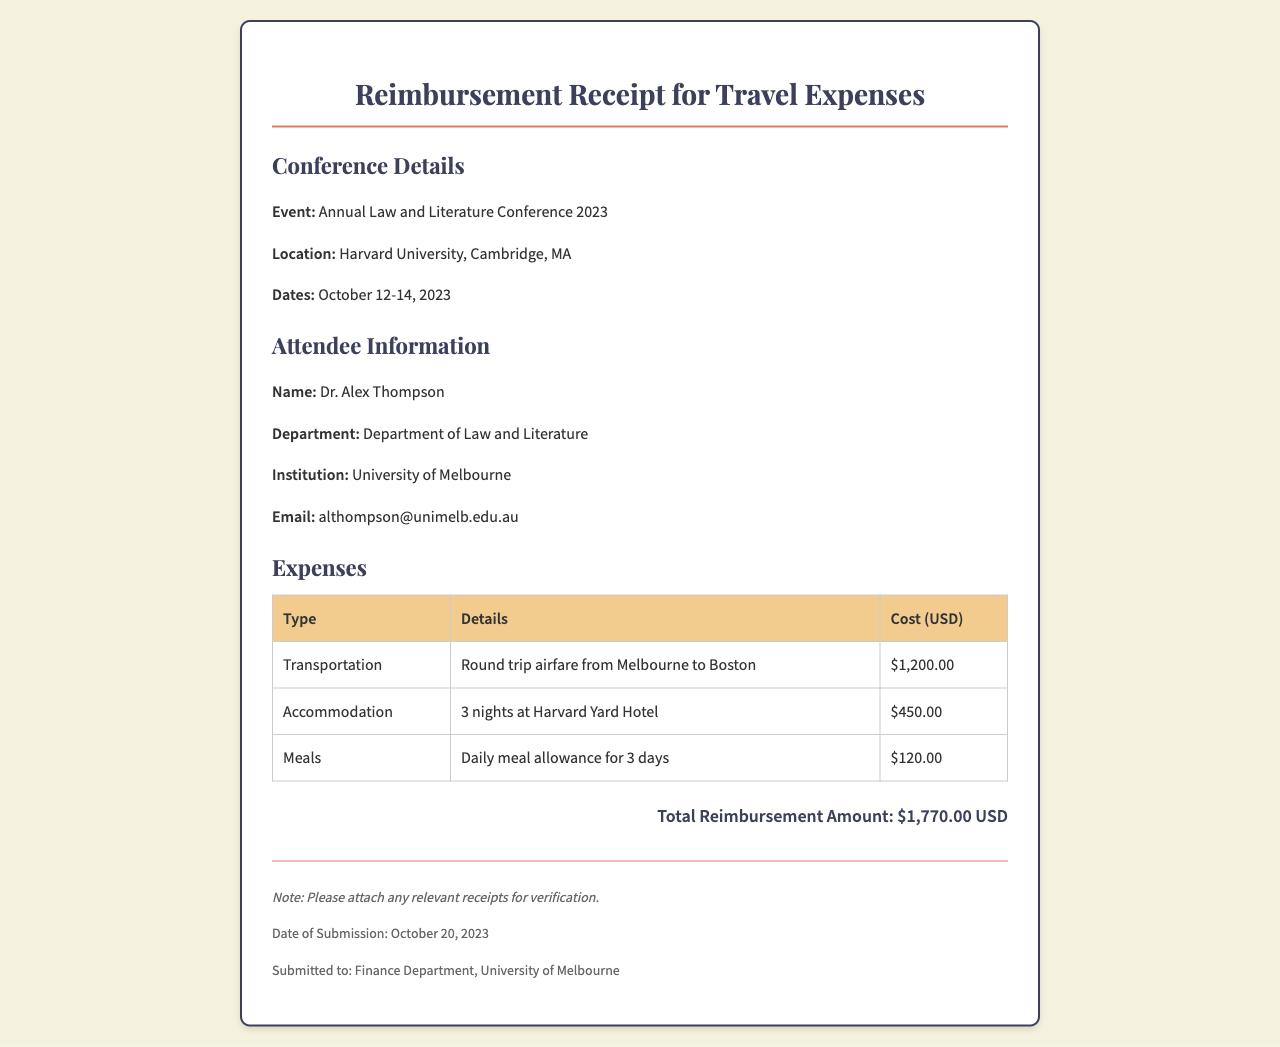What is the event name? The event name is specified in the conference details section of the document as "Annual Law and Literature Conference 2023."
Answer: Annual Law and Literature Conference 2023 Where was the conference held? The location of the conference is mentioned in the document under conference details as "Harvard University, Cambridge, MA."
Answer: Harvard University, Cambridge, MA Who submitted the reimbursement receipt? The name of the person who submitted the receipt can be found in the attendee information section, which states "Dr. Alex Thompson."
Answer: Dr. Alex Thompson What is the total reimbursement amount? The total reimbursement amount is listed in the total section of the document as "$1,770.00 USD."
Answer: $1,770.00 USD How many nights did the attendee stay at the hotel? The document mentions "3 nights" in the accommodation expense details.
Answer: 3 nights What type of transportation is listed? The type of transportation is specified in the expenses table as "Round trip airfare from Melbourne to Boston."
Answer: Round trip airfare from Melbourne to Boston What is the meal allowance amount? The routine mentioned for meals states "Daily meal allowance for 3 days," with a total amount of "$120.00."
Answer: $120.00 What date was the receipt submitted? The date of submission is stated in the footer of the document as "October 20, 2023."
Answer: October 20, 2023 Which department received the submitted receipt? The document specifies in the footer that the receipt was submitted to the "Finance Department, University of Melbourne."
Answer: Finance Department, University of Melbourne 